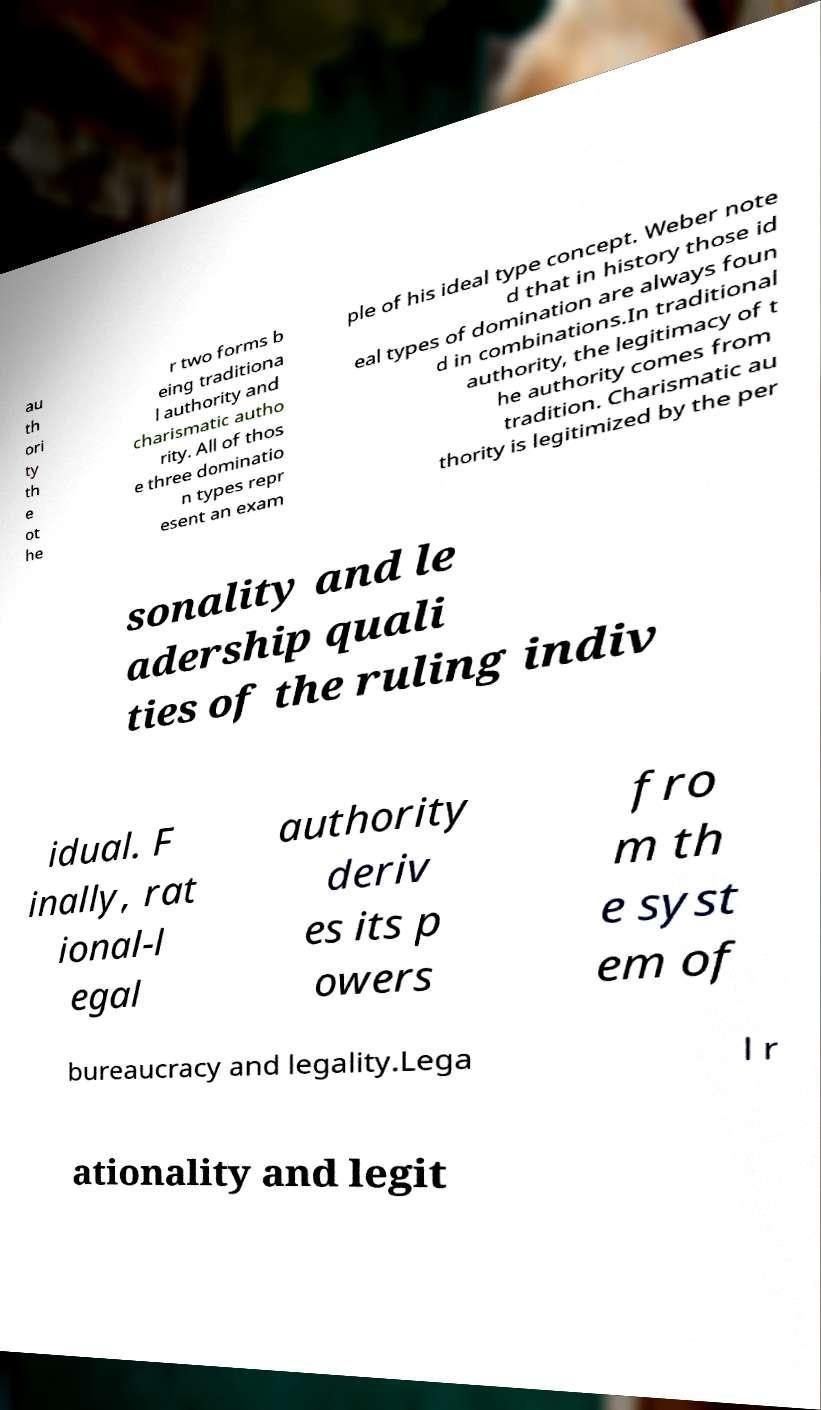Can you accurately transcribe the text from the provided image for me? au th ori ty th e ot he r two forms b eing traditiona l authority and charismatic autho rity. All of thos e three dominatio n types repr esent an exam ple of his ideal type concept. Weber note d that in history those id eal types of domination are always foun d in combinations.In traditional authority, the legitimacy of t he authority comes from tradition. Charismatic au thority is legitimized by the per sonality and le adership quali ties of the ruling indiv idual. F inally, rat ional-l egal authority deriv es its p owers fro m th e syst em of bureaucracy and legality.Lega l r ationality and legit 